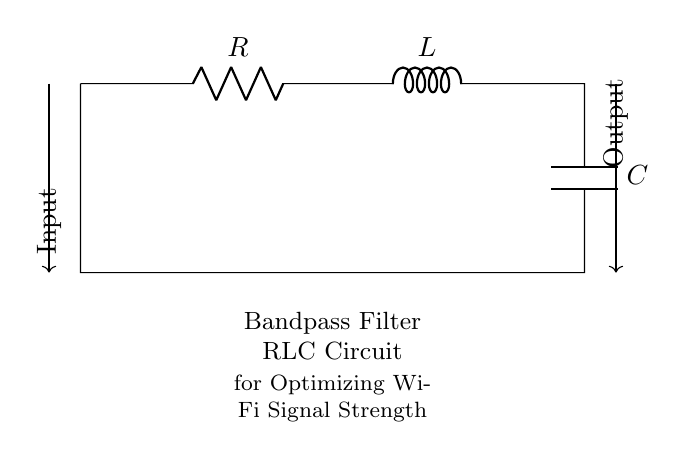What type of filter is this circuit? The circuit is a bandpass filter, which means it allows signals within a certain frequency range to pass while attenuating signals outside that range. This information is derived from the labeling "Bandpass Filter RLC Circuit" at the bottom of the diagram.
Answer: Bandpass filter What components are present in this circuit? The circuit contains three primary components: a resistor, an inductor, and a capacitor. Each component is labeled in the diagram with their respective symbols, indicating their presence and roles within the circuit.
Answer: Resistor, Inductor, Capacitor What is the function of the capacitor in this circuit? The capacitor in a bandpass filter circuit is responsible for allowing high-frequency signals to pass through when paired with the inductor, while blocking low-frequency signals. This function is an essential characteristic of a capacitor in tuned circuits.
Answer: Block low frequencies What is the connection type between the resistor, inductor, and capacitor? The connection type among the resistor, inductor, and capacitor is in series. This means that the components are connected end-to-end and share the same current flowing through them, a common configuration for building a bandpass filter.
Answer: Series connection How does the inductor affect the circuit's behavior at different frequencies? The inductor behaves as a short circuit at low frequencies and acts as an open circuit at high frequencies. This means that at low frequencies, it allows current to flow, while at high frequencies, it impedes the flow, playing a critical role in shaping the frequency response of the bandpass filter.
Answer: Short at low frequency, open at high frequency What is the purpose of this bandpass filter? The purpose of this bandpass filter is to optimize Wi-Fi signal strength throughout the property, which is indicated in the text below the circuit diagram. It serves to enhance the quality of the Wi-Fi signals by allowing only a specific range of frequencies that are beneficial for signal transmission.
Answer: Optimize Wi-Fi signal strength 